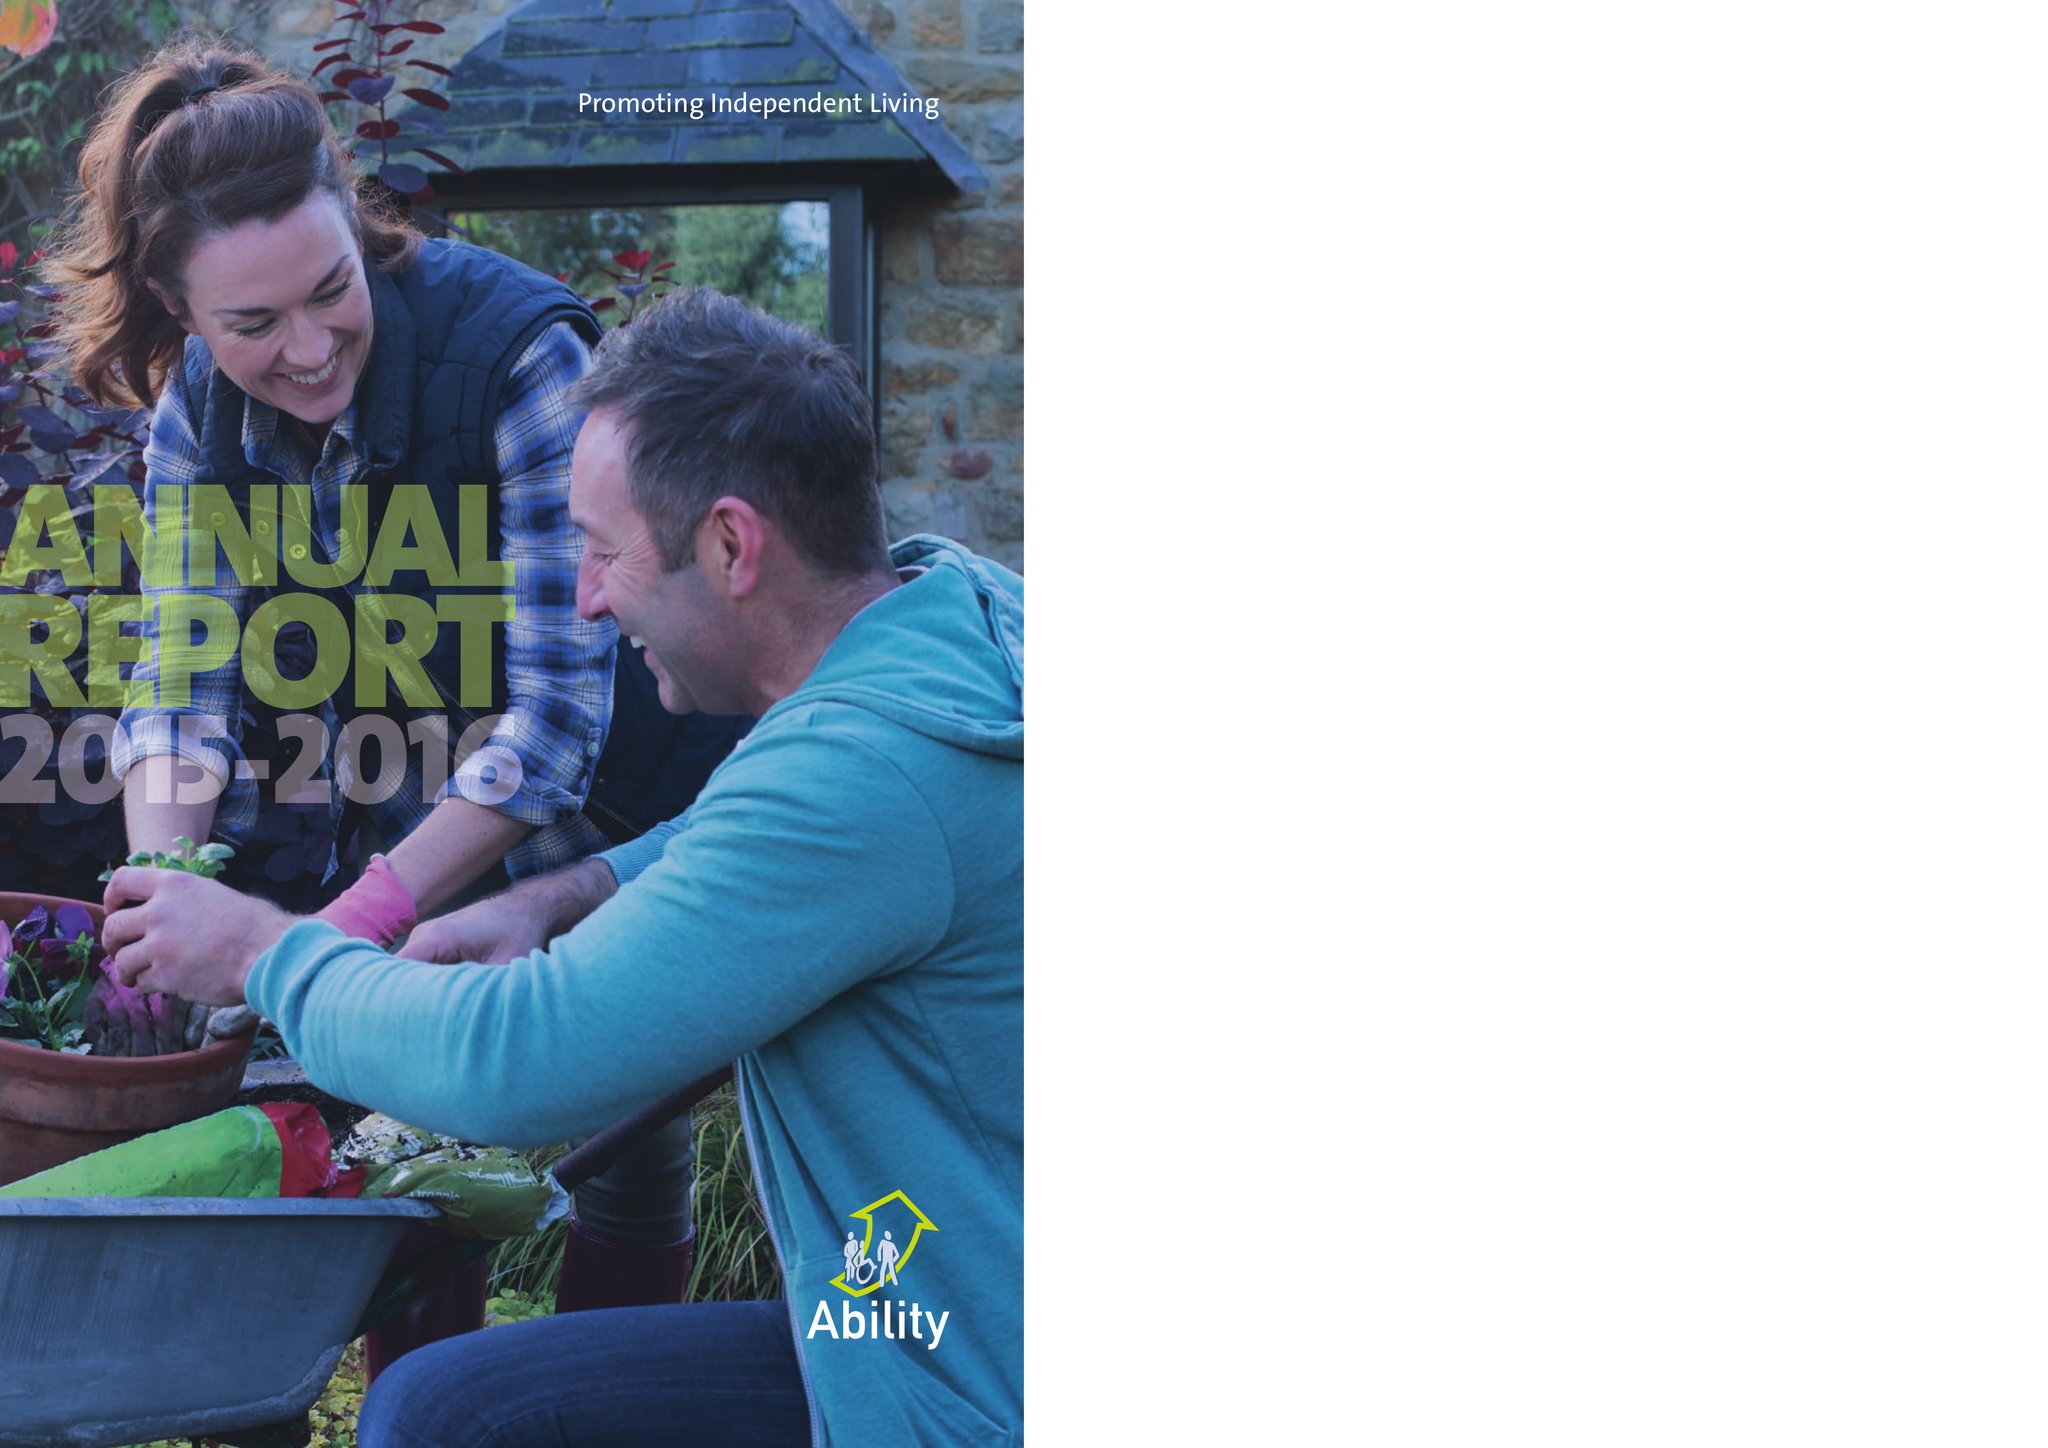What is the value for the charity_number?
Answer the question using a single word or phrase. 271547 